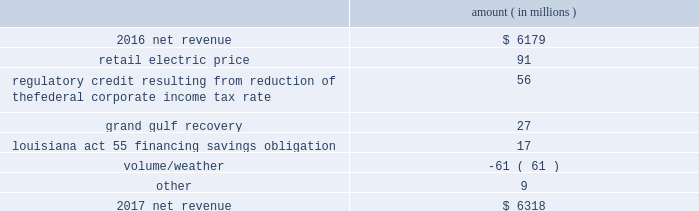Results of operations for 2016 include : 1 ) $ 2836 million ( $ 1829 million net-of-tax ) of impairment and related charges primarily to write down the carrying values of the entergy wholesale commodities 2019 palisades , indian point 2 , and indian point 3 plants and related assets to their fair values ; 2 ) a reduction of income tax expense , net of unrecognized tax benefits , of $ 238 million as a result of a change in the tax classification of a legal entity that owned one of the entergy wholesale commodities nuclear power plants ; income tax benefits as a result of the settlement of the 2010-2011 irs audit , including a $ 75 million tax benefit recognized by entergy louisiana related to the treatment of the vidalia purchased power agreement and a $ 54 million net benefit recognized by entergy louisiana related to the treatment of proceeds received in 2010 for the financing of hurricane gustav and hurricane ike storm costs pursuant to louisiana act 55 ; and 3 ) a reduction in expenses of $ 100 million ( $ 64 million net-of-tax ) due to the effects of recording in 2016 the final court decisions in several lawsuits against the doe related to spent nuclear fuel storage costs .
See note 14 to the financial statements for further discussion of the impairment and related charges , see note 3 to the financial statements for additional discussion of the income tax items , and see note 8 to the financial statements for discussion of the spent nuclear fuel litigation .
Net revenue utility following is an analysis of the change in net revenue comparing 2017 to 2016 .
Amount ( in millions ) .
The retail electric price variance is primarily due to : 2022 the implementation of formula rate plan rates effective with the first billing cycle of january 2017 at entergy arkansas and an increase in base rates effective february 24 , 2016 , each as approved by the apsc .
A significant portion of the base rate increase was related to the purchase of power block 2 of the union power station in march 2016 ; 2022 a provision recorded in 2016 related to the settlement of the waterford 3 replacement steam generator prudence review proceeding ; 2022 the implementation of the transmission cost recovery factor rider at entergy texas , effective september 2016 , and an increase in the transmission cost recovery factor rider rate , effective march 2017 , as approved by the puct ; and 2022 an increase in rates at entergy mississippi , as approved by the mpsc , effective with the first billing cycle of july 2016 .
See note 2 to the financial statements for further discussion of the rate proceedings and the waterford 3 replacement steam generator prudence review proceeding .
See note 14 to the financial statements for discussion of the union power station purchase .
Entergy corporation and subsidiaries management 2019s financial discussion and analysis .
What is the reduction of income tax expense as a percentage of net revenue in 2016? 
Computations: (238 / 6179)
Answer: 0.03852. 